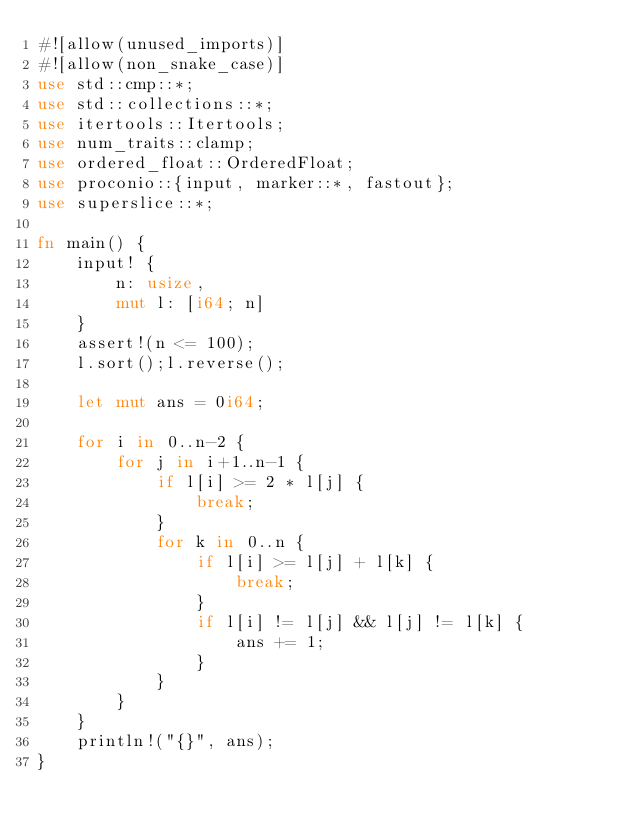<code> <loc_0><loc_0><loc_500><loc_500><_Rust_>#![allow(unused_imports)]
#![allow(non_snake_case)]
use std::cmp::*;
use std::collections::*;
use itertools::Itertools;
use num_traits::clamp;
use ordered_float::OrderedFloat;
use proconio::{input, marker::*, fastout};
use superslice::*;

fn main() {
    input! {
        n: usize,
        mut l: [i64; n]
    }
    assert!(n <= 100);
    l.sort();l.reverse();
    
    let mut ans = 0i64;

    for i in 0..n-2 {
        for j in i+1..n-1 {
            if l[i] >= 2 * l[j] {
                break;
            }
            for k in 0..n {
                if l[i] >= l[j] + l[k] {
                    break;
                }
                if l[i] != l[j] && l[j] != l[k] {
                    ans += 1;
                }
            }
        }
    }
    println!("{}", ans);
}
</code> 